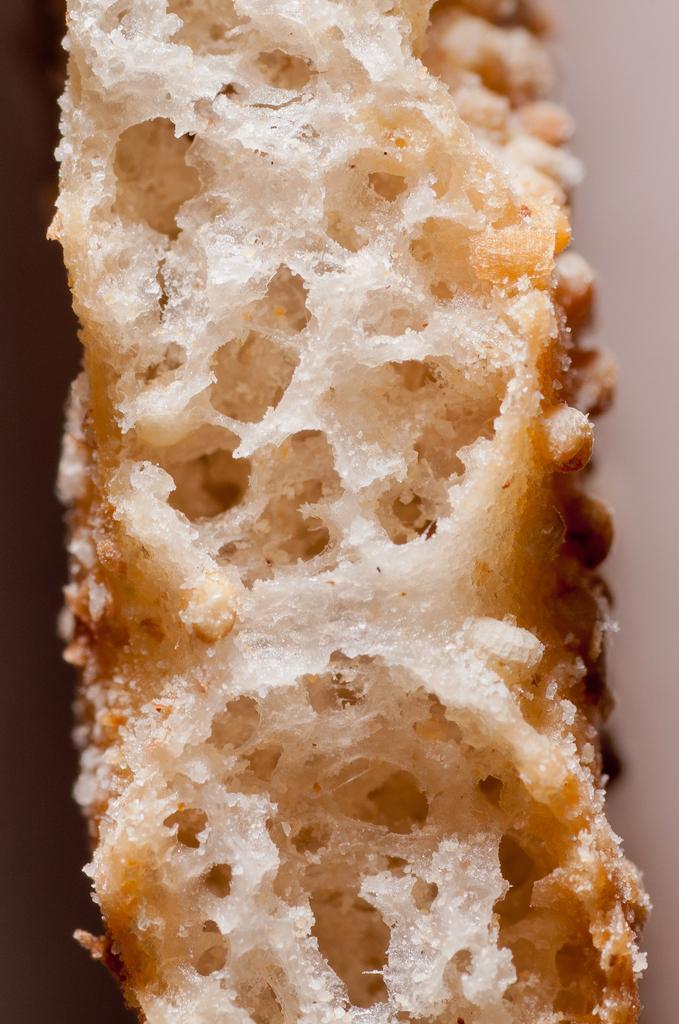Describe this image in one or two sentences. In the picture I can see something which looks like a food item. 